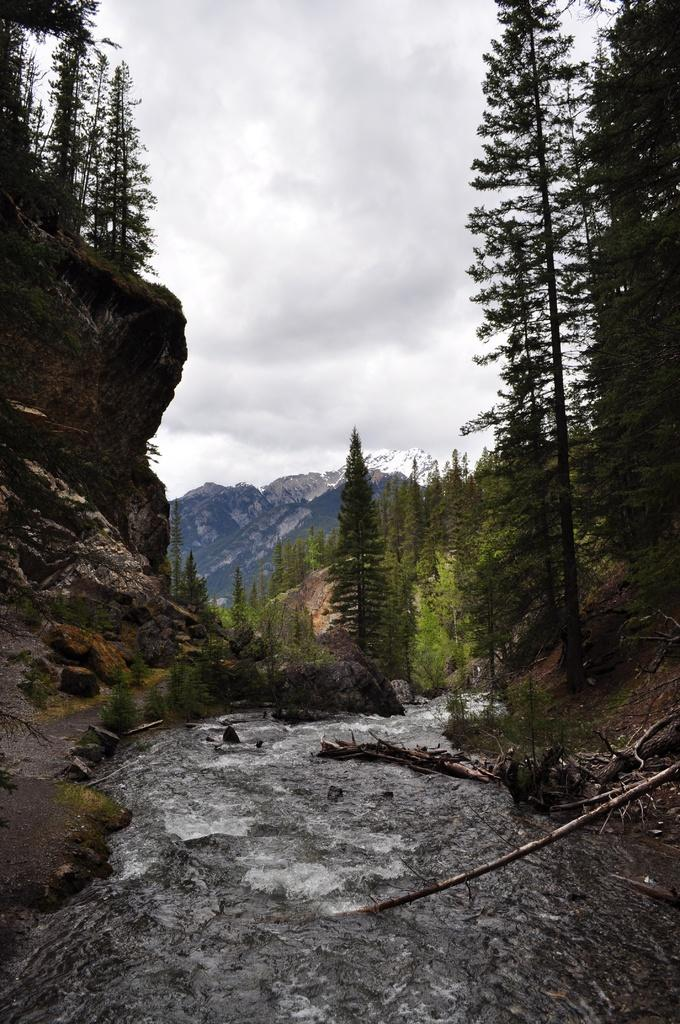What type of natural feature is present in the image? There is a river in the image. What can be found around the river? There are plants and trees around the river. What is visible in the background of the image? There are mountains visible in the background of the image. Where is the cannon located in the image? There is no cannon present in the image. What type of tool is being used to rake the plants in the image? There is no rake or any tool being used to rake the plants in the image; the plants are simply growing around the river. 